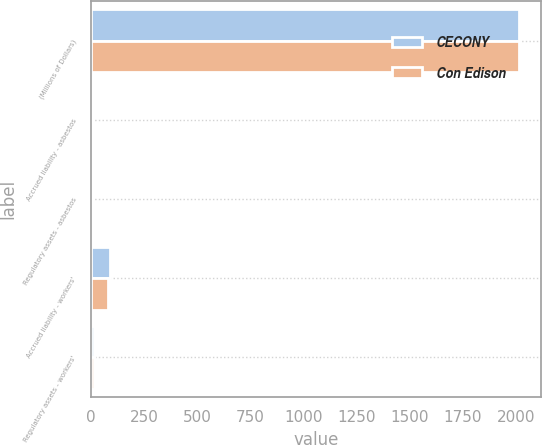<chart> <loc_0><loc_0><loc_500><loc_500><stacked_bar_chart><ecel><fcel>(Millions of Dollars)<fcel>Accrued liability - asbestos<fcel>Regulatory assets - asbestos<fcel>Accrued liability - workers'<fcel>Regulatory assets - workers'<nl><fcel>CECONY<fcel>2016<fcel>8<fcel>8<fcel>88<fcel>13<nl><fcel>Con Edison<fcel>2016<fcel>7<fcel>7<fcel>83<fcel>13<nl></chart> 